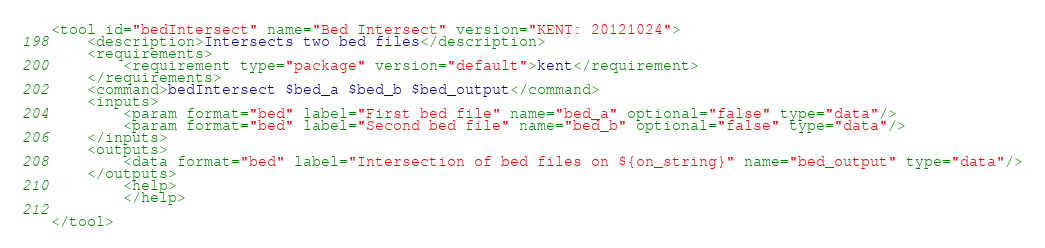<code> <loc_0><loc_0><loc_500><loc_500><_XML_><tool id="bedIntersect" name="Bed Intersect" version="KENT: 20121024">
	<description>Intersects two bed files</description>
	<requirements>
		<requirement type="package" version="default">kent</requirement>
	</requirements>
	<command>bedIntersect $bed_a $bed_b $bed_output</command>
	<inputs>
		<param format="bed" label="First bed file" name="bed_a" optional="false" type="data"/>
		<param format="bed" label="Second bed file" name="bed_b" optional="false" type="data"/>
	</inputs>
	<outputs>
		<data format="bed" label="Intersection of bed files on ${on_string}" name="bed_output" type="data"/>
	</outputs>
        <help>
        </help>

</tool></code> 